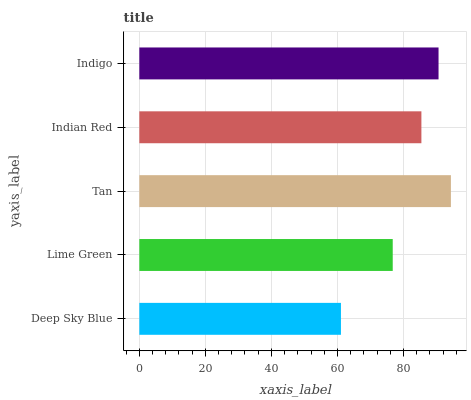Is Deep Sky Blue the minimum?
Answer yes or no. Yes. Is Tan the maximum?
Answer yes or no. Yes. Is Lime Green the minimum?
Answer yes or no. No. Is Lime Green the maximum?
Answer yes or no. No. Is Lime Green greater than Deep Sky Blue?
Answer yes or no. Yes. Is Deep Sky Blue less than Lime Green?
Answer yes or no. Yes. Is Deep Sky Blue greater than Lime Green?
Answer yes or no. No. Is Lime Green less than Deep Sky Blue?
Answer yes or no. No. Is Indian Red the high median?
Answer yes or no. Yes. Is Indian Red the low median?
Answer yes or no. Yes. Is Deep Sky Blue the high median?
Answer yes or no. No. Is Deep Sky Blue the low median?
Answer yes or no. No. 